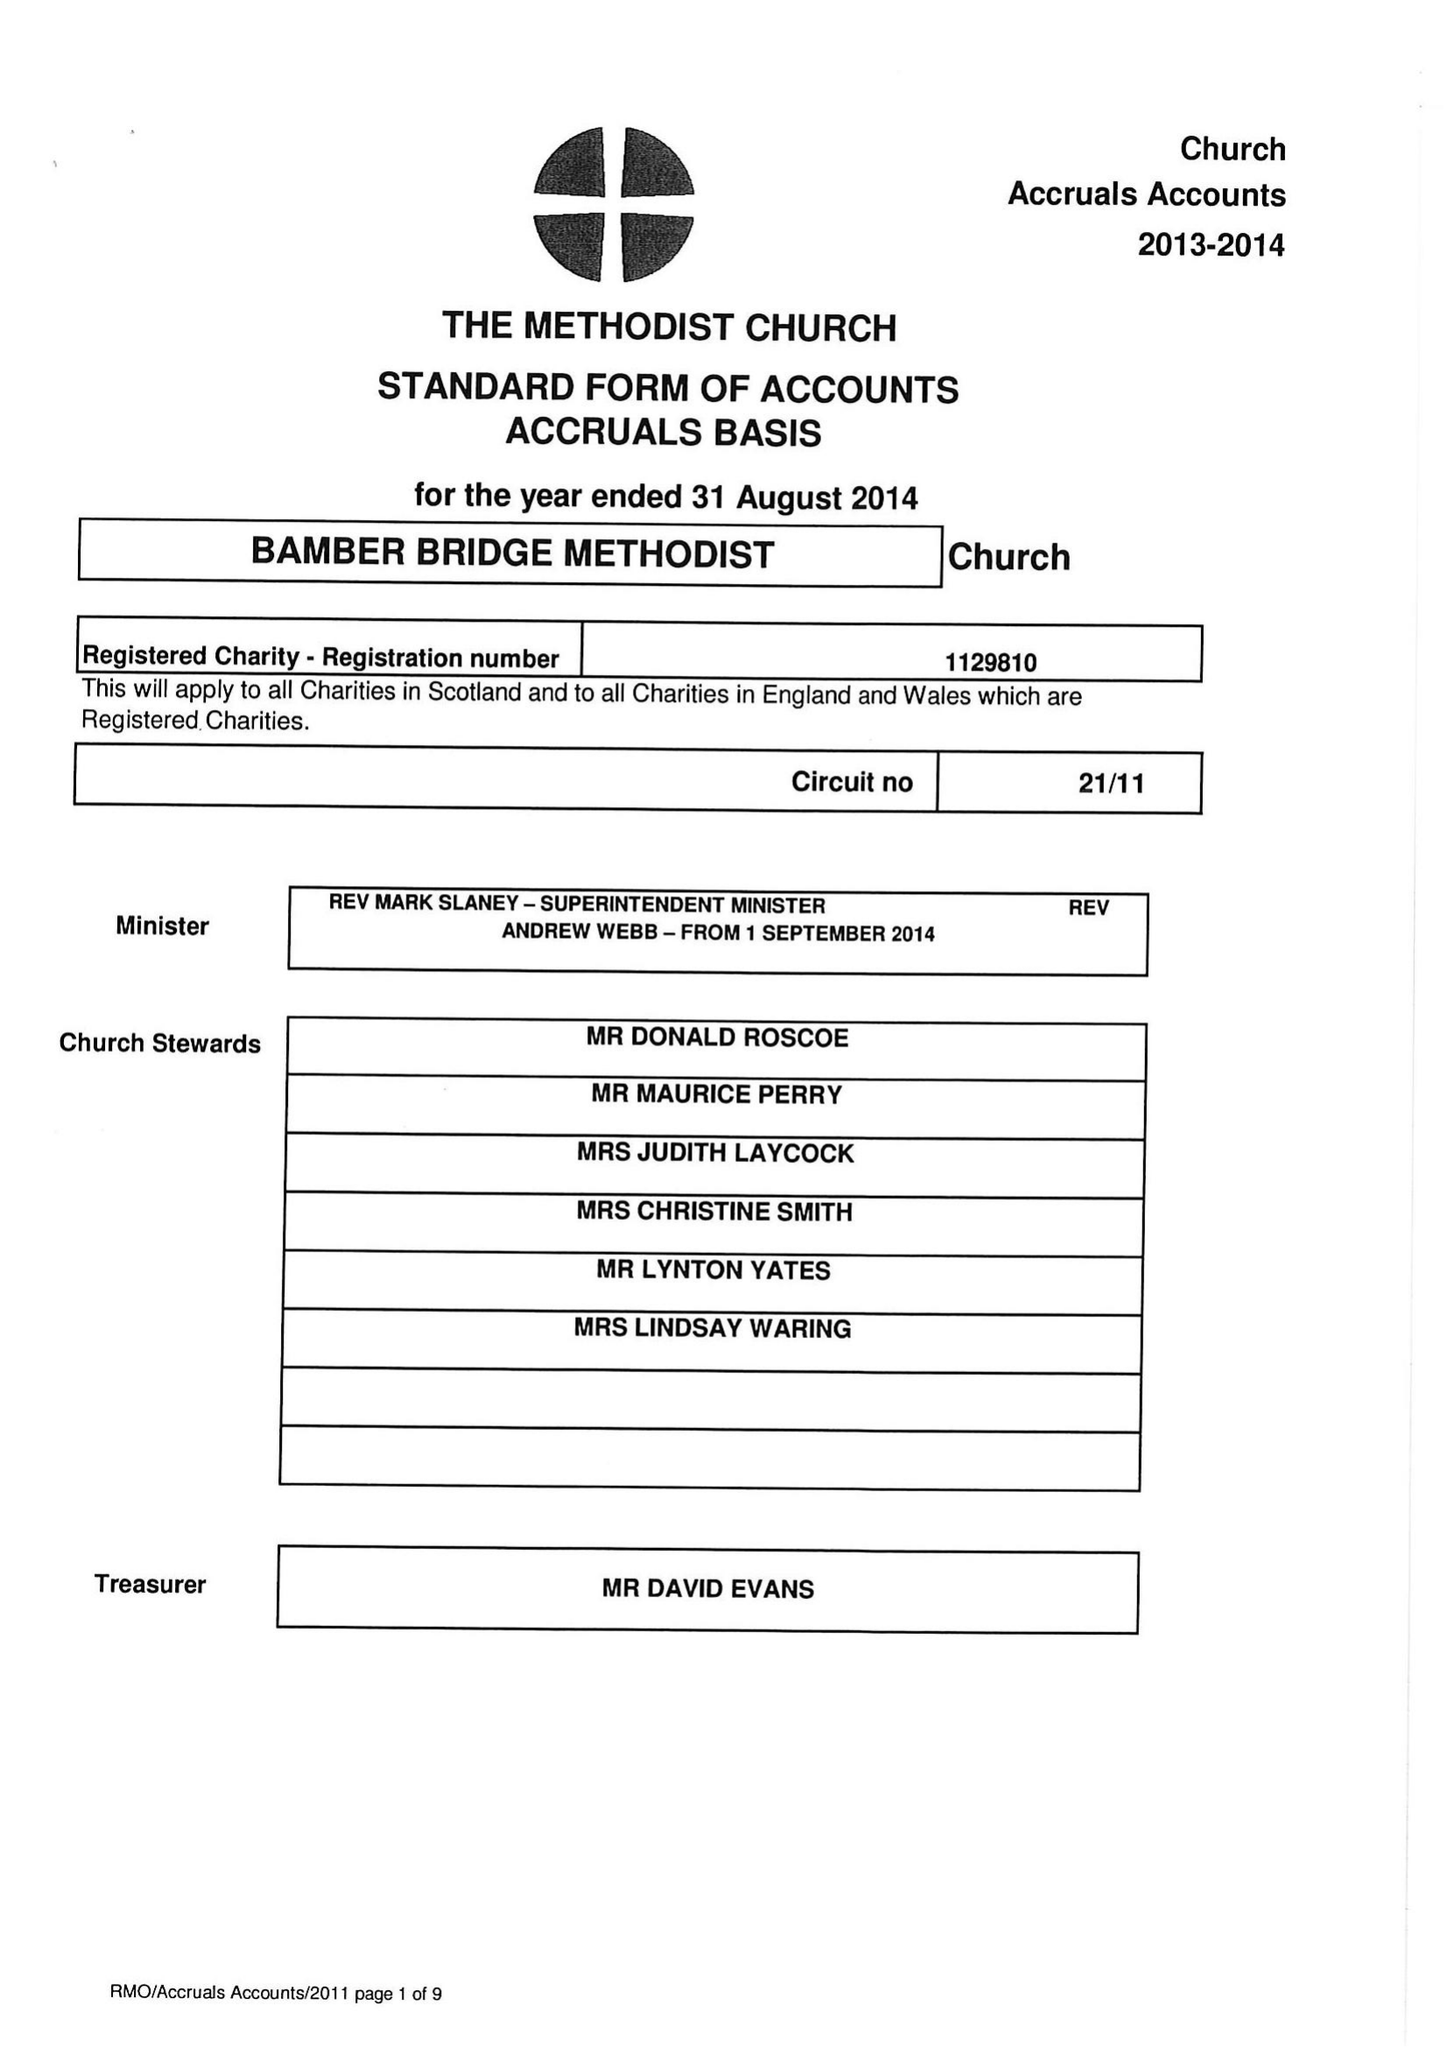What is the value for the charity_name?
Answer the question using a single word or phrase. Bamber Bridge Methodist Church 